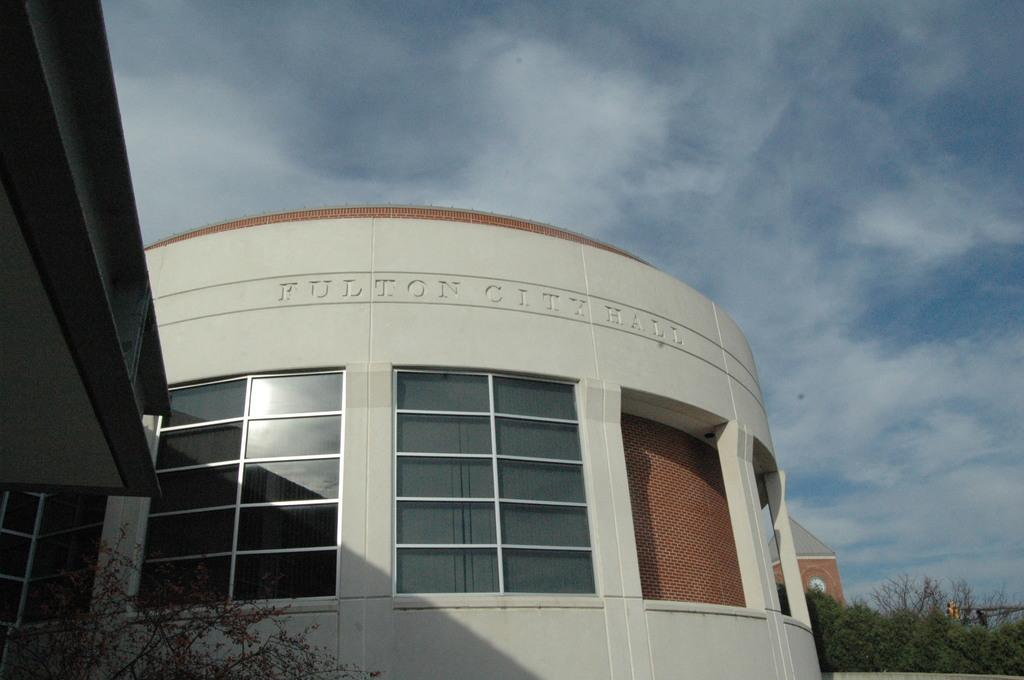What is the main structure in the center of the image? There is a building with windows in the center of the image. What can be seen at the top of the image? The sky is visible at the top of the image. What type of natural elements are present in the background of the image? There are trees in the background of the image. Can you see any goldfish swimming in the image? There are no goldfish present in the image. Is there a garden visible in the image? There is no garden visible in the image. 